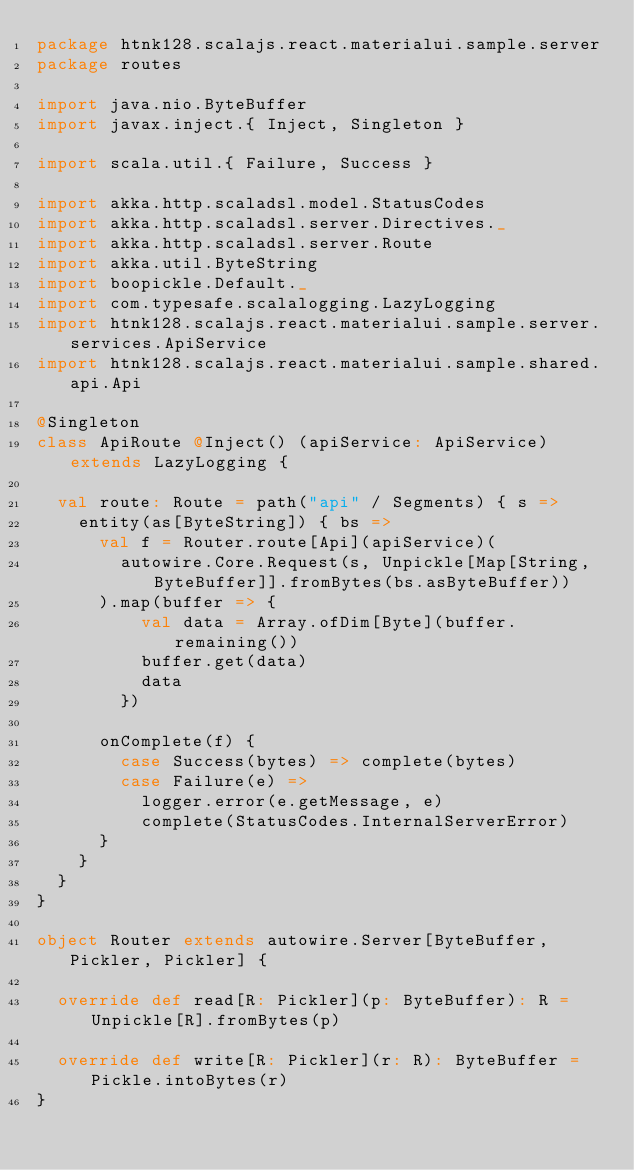<code> <loc_0><loc_0><loc_500><loc_500><_Scala_>package htnk128.scalajs.react.materialui.sample.server
package routes

import java.nio.ByteBuffer
import javax.inject.{ Inject, Singleton }

import scala.util.{ Failure, Success }

import akka.http.scaladsl.model.StatusCodes
import akka.http.scaladsl.server.Directives._
import akka.http.scaladsl.server.Route
import akka.util.ByteString
import boopickle.Default._
import com.typesafe.scalalogging.LazyLogging
import htnk128.scalajs.react.materialui.sample.server.services.ApiService
import htnk128.scalajs.react.materialui.sample.shared.api.Api

@Singleton
class ApiRoute @Inject() (apiService: ApiService) extends LazyLogging {

  val route: Route = path("api" / Segments) { s =>
    entity(as[ByteString]) { bs =>
      val f = Router.route[Api](apiService)(
        autowire.Core.Request(s, Unpickle[Map[String, ByteBuffer]].fromBytes(bs.asByteBuffer))
      ).map(buffer => {
          val data = Array.ofDim[Byte](buffer.remaining())
          buffer.get(data)
          data
        })

      onComplete(f) {
        case Success(bytes) => complete(bytes)
        case Failure(e) =>
          logger.error(e.getMessage, e)
          complete(StatusCodes.InternalServerError)
      }
    }
  }
}

object Router extends autowire.Server[ByteBuffer, Pickler, Pickler] {

  override def read[R: Pickler](p: ByteBuffer): R = Unpickle[R].fromBytes(p)

  override def write[R: Pickler](r: R): ByteBuffer = Pickle.intoBytes(r)
}
</code> 